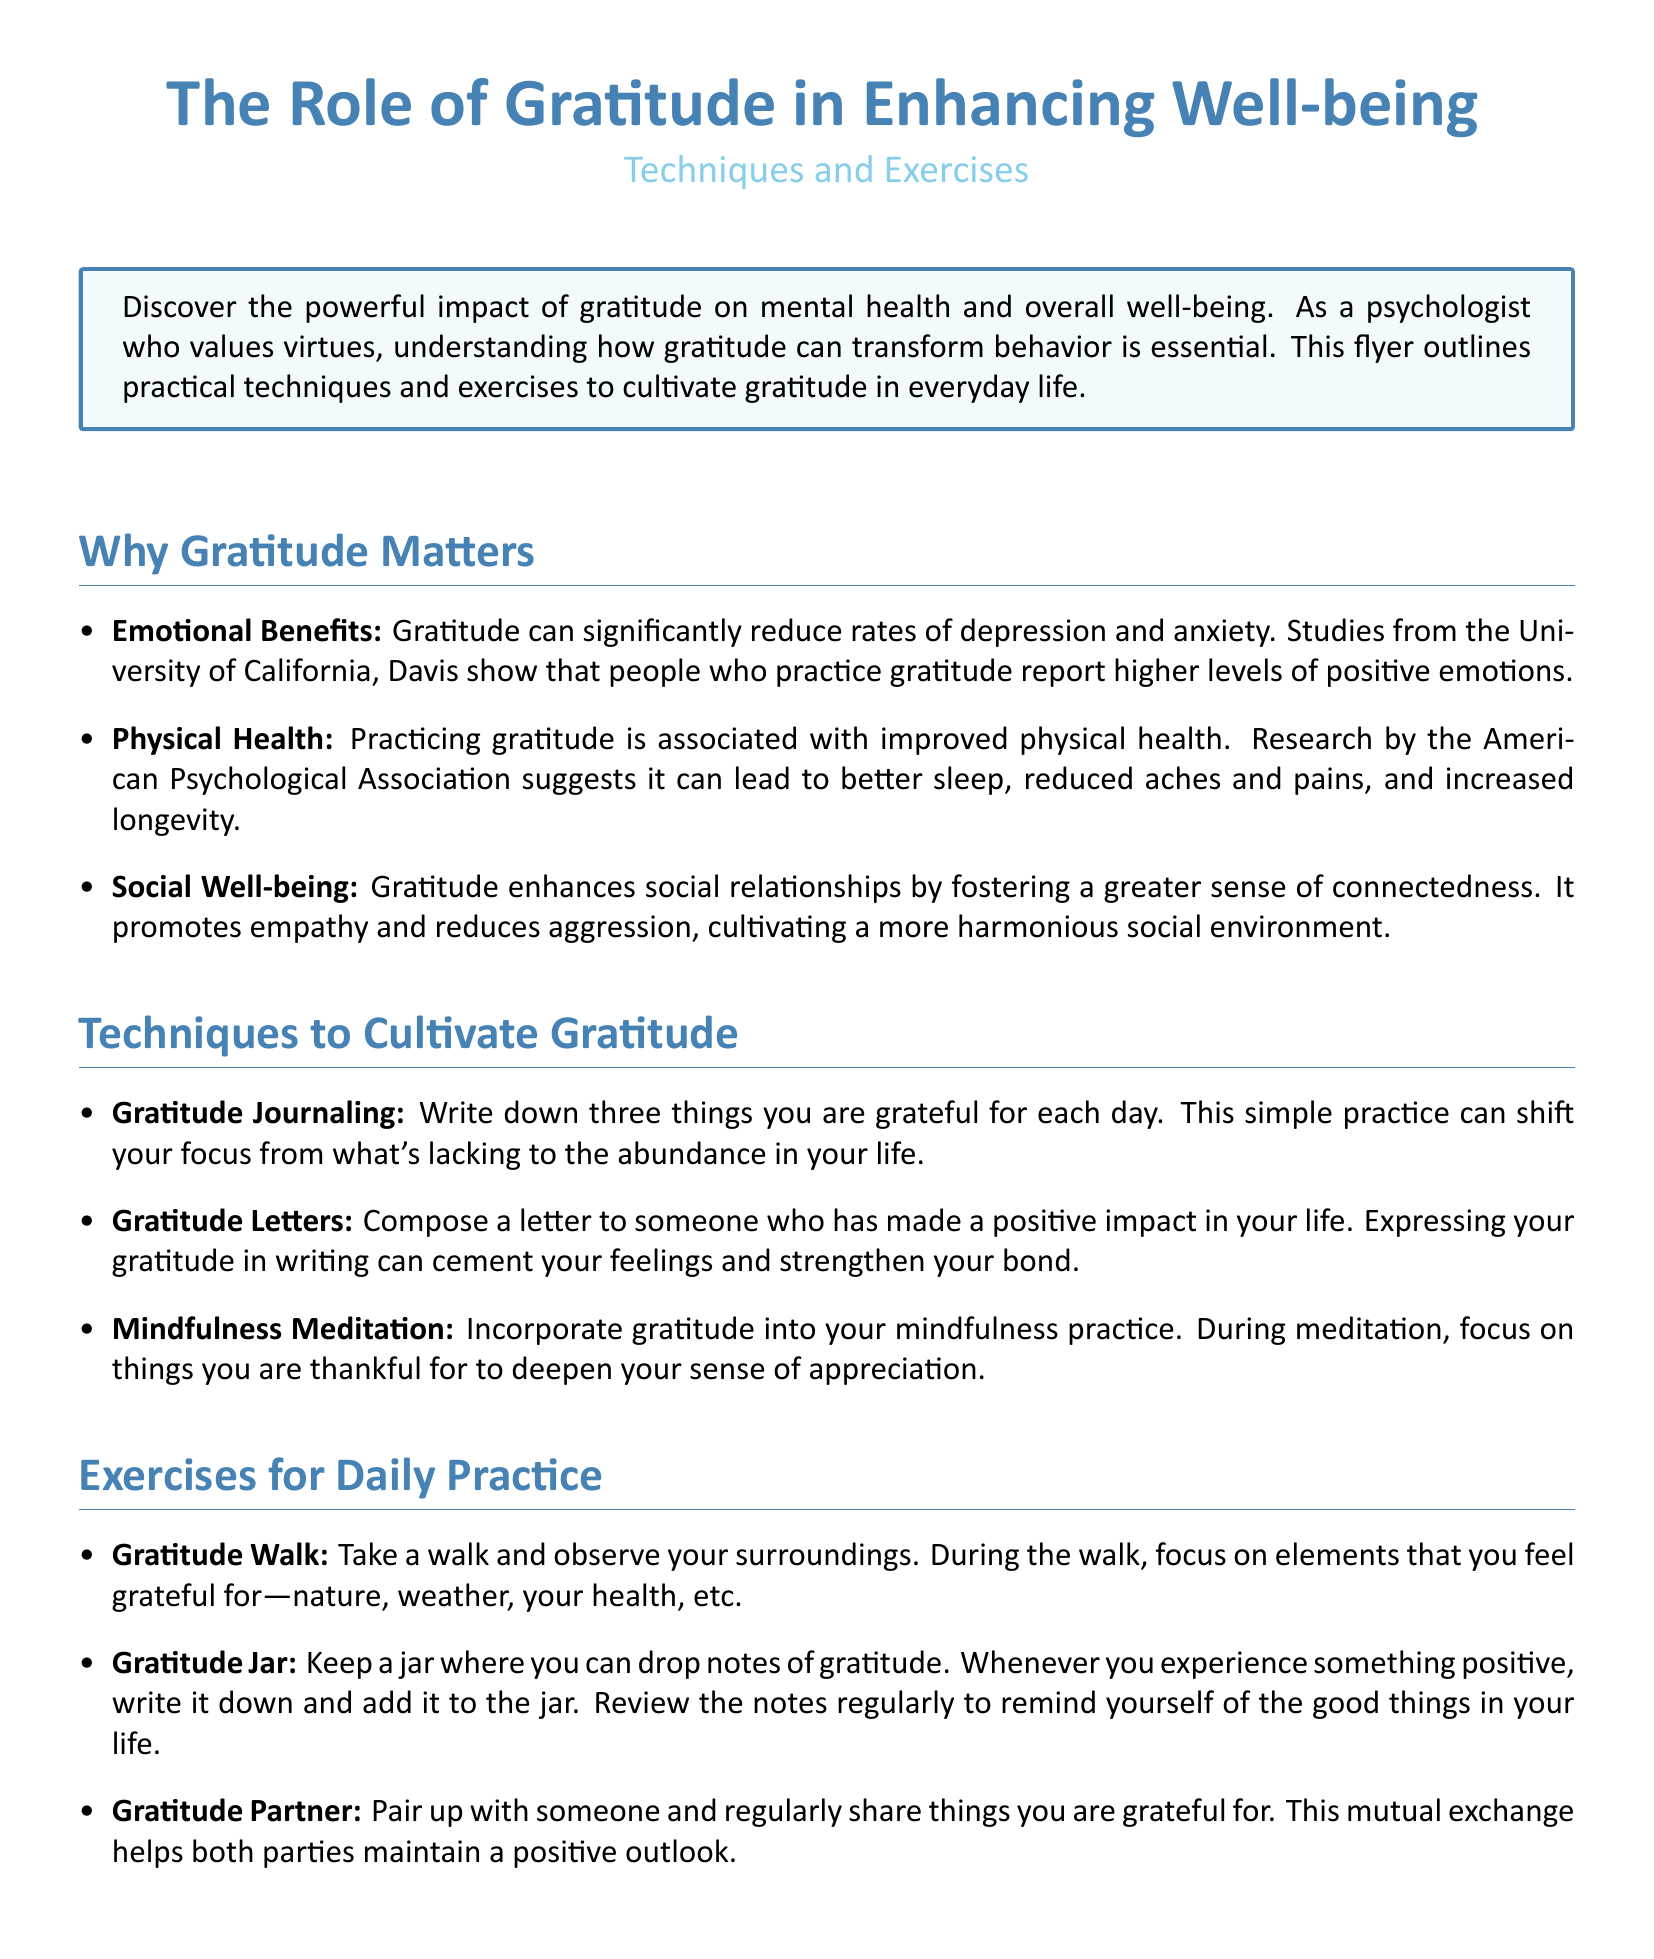What are the emotional benefits of gratitude? The emotional benefits of gratitude include significantly reducing rates of depression and anxiety and reporting higher levels of positive emotions.
Answer: Reducing depression and anxiety What technique involves writing down things you are thankful for? The technique that involves writing down things you are thankful for is known as gratitude journaling.
Answer: Gratitude journaling Which university's studies indicate that gratitude is associated with greater happiness? The studies indicating that gratitude is associated with greater happiness were conducted by the University of California, Davis.
Answer: University of California, Davis What is one exercise mentioned for daily practice of gratitude? One exercise mentioned for daily practice of gratitude is the gratitude walk.
Answer: Gratitude walk What color is primarily used for the section headings in the document? The color primarily used for section headings in the document is maincolor, which is RGB (70,130,180).
Answer: Maincolor How many gratitude techniques are listed in the document? There are three gratitude techniques listed in the document.
Answer: Three What is the conclusion regarding the incorporation of gratitude? The conclusion states that incorporating gratitude into daily life can yield profound benefits for mental, physical, and social well-being.
Answer: Profound benefits What province does the research evidence come from that discusses health benefits of gratitude? The research evidence discussing health benefits of gratitude comes from the American Psychological Association.
Answer: American Psychological Association 